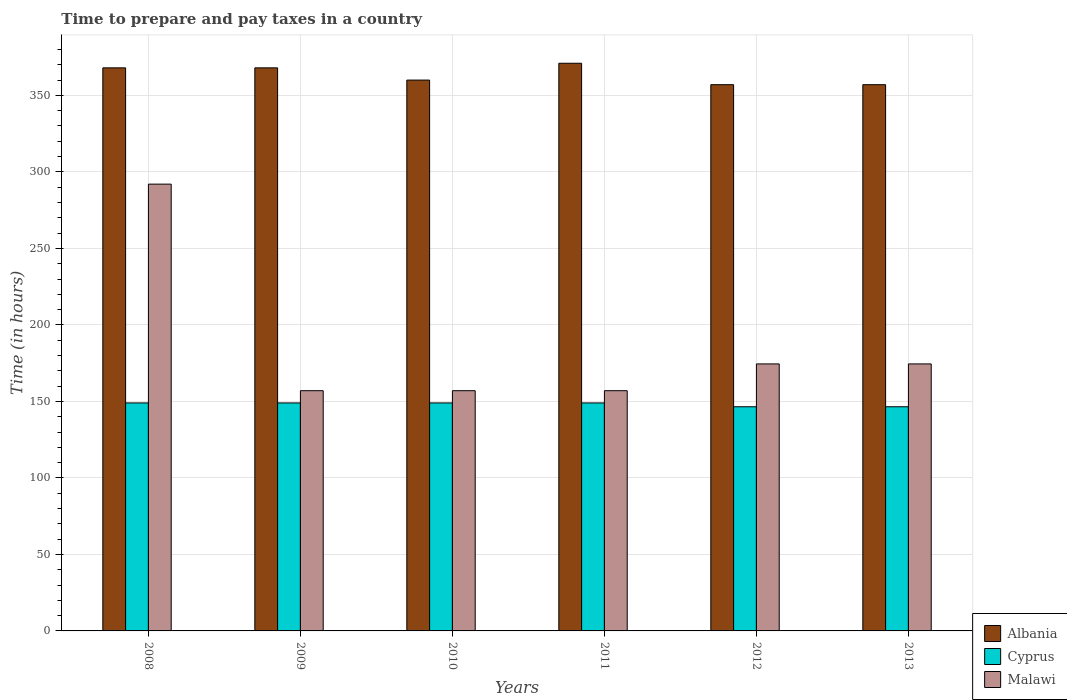How many different coloured bars are there?
Provide a succinct answer. 3. How many groups of bars are there?
Make the answer very short. 6. Are the number of bars per tick equal to the number of legend labels?
Offer a very short reply. Yes. How many bars are there on the 4th tick from the left?
Ensure brevity in your answer.  3. How many bars are there on the 4th tick from the right?
Offer a terse response. 3. In how many cases, is the number of bars for a given year not equal to the number of legend labels?
Your answer should be very brief. 0. What is the number of hours required to prepare and pay taxes in Cyprus in 2012?
Your answer should be compact. 146.5. Across all years, what is the maximum number of hours required to prepare and pay taxes in Malawi?
Your answer should be very brief. 292. Across all years, what is the minimum number of hours required to prepare and pay taxes in Cyprus?
Ensure brevity in your answer.  146.5. In which year was the number of hours required to prepare and pay taxes in Malawi maximum?
Provide a succinct answer. 2008. What is the total number of hours required to prepare and pay taxes in Malawi in the graph?
Provide a succinct answer. 1112. What is the difference between the number of hours required to prepare and pay taxes in Malawi in 2010 and that in 2012?
Provide a succinct answer. -17.5. What is the difference between the number of hours required to prepare and pay taxes in Malawi in 2011 and the number of hours required to prepare and pay taxes in Albania in 2012?
Make the answer very short. -200. What is the average number of hours required to prepare and pay taxes in Cyprus per year?
Your answer should be compact. 148.17. In the year 2009, what is the difference between the number of hours required to prepare and pay taxes in Cyprus and number of hours required to prepare and pay taxes in Albania?
Ensure brevity in your answer.  -219. What is the ratio of the number of hours required to prepare and pay taxes in Albania in 2011 to that in 2013?
Offer a very short reply. 1.04. Is the number of hours required to prepare and pay taxes in Malawi in 2008 less than that in 2009?
Offer a terse response. No. Is the difference between the number of hours required to prepare and pay taxes in Cyprus in 2009 and 2013 greater than the difference between the number of hours required to prepare and pay taxes in Albania in 2009 and 2013?
Offer a terse response. No. What is the difference between the highest and the lowest number of hours required to prepare and pay taxes in Cyprus?
Your answer should be very brief. 2.5. In how many years, is the number of hours required to prepare and pay taxes in Cyprus greater than the average number of hours required to prepare and pay taxes in Cyprus taken over all years?
Make the answer very short. 4. Is the sum of the number of hours required to prepare and pay taxes in Cyprus in 2008 and 2009 greater than the maximum number of hours required to prepare and pay taxes in Albania across all years?
Give a very brief answer. No. What does the 1st bar from the left in 2009 represents?
Make the answer very short. Albania. What does the 3rd bar from the right in 2012 represents?
Give a very brief answer. Albania. Is it the case that in every year, the sum of the number of hours required to prepare and pay taxes in Cyprus and number of hours required to prepare and pay taxes in Malawi is greater than the number of hours required to prepare and pay taxes in Albania?
Your response must be concise. No. Does the graph contain any zero values?
Provide a short and direct response. No. How are the legend labels stacked?
Keep it short and to the point. Vertical. What is the title of the graph?
Your answer should be very brief. Time to prepare and pay taxes in a country. Does "Austria" appear as one of the legend labels in the graph?
Provide a succinct answer. No. What is the label or title of the X-axis?
Offer a very short reply. Years. What is the label or title of the Y-axis?
Ensure brevity in your answer.  Time (in hours). What is the Time (in hours) in Albania in 2008?
Ensure brevity in your answer.  368. What is the Time (in hours) in Cyprus in 2008?
Give a very brief answer. 149. What is the Time (in hours) in Malawi in 2008?
Give a very brief answer. 292. What is the Time (in hours) of Albania in 2009?
Offer a very short reply. 368. What is the Time (in hours) in Cyprus in 2009?
Give a very brief answer. 149. What is the Time (in hours) in Malawi in 2009?
Your answer should be very brief. 157. What is the Time (in hours) of Albania in 2010?
Offer a terse response. 360. What is the Time (in hours) in Cyprus in 2010?
Ensure brevity in your answer.  149. What is the Time (in hours) of Malawi in 2010?
Keep it short and to the point. 157. What is the Time (in hours) of Albania in 2011?
Offer a very short reply. 371. What is the Time (in hours) in Cyprus in 2011?
Your response must be concise. 149. What is the Time (in hours) in Malawi in 2011?
Provide a succinct answer. 157. What is the Time (in hours) of Albania in 2012?
Ensure brevity in your answer.  357. What is the Time (in hours) in Cyprus in 2012?
Keep it short and to the point. 146.5. What is the Time (in hours) in Malawi in 2012?
Offer a very short reply. 174.5. What is the Time (in hours) in Albania in 2013?
Give a very brief answer. 357. What is the Time (in hours) of Cyprus in 2013?
Offer a terse response. 146.5. What is the Time (in hours) in Malawi in 2013?
Provide a short and direct response. 174.5. Across all years, what is the maximum Time (in hours) of Albania?
Your answer should be compact. 371. Across all years, what is the maximum Time (in hours) of Cyprus?
Keep it short and to the point. 149. Across all years, what is the maximum Time (in hours) of Malawi?
Make the answer very short. 292. Across all years, what is the minimum Time (in hours) of Albania?
Offer a terse response. 357. Across all years, what is the minimum Time (in hours) in Cyprus?
Your response must be concise. 146.5. Across all years, what is the minimum Time (in hours) in Malawi?
Ensure brevity in your answer.  157. What is the total Time (in hours) in Albania in the graph?
Give a very brief answer. 2181. What is the total Time (in hours) of Cyprus in the graph?
Your answer should be compact. 889. What is the total Time (in hours) in Malawi in the graph?
Ensure brevity in your answer.  1112. What is the difference between the Time (in hours) of Albania in 2008 and that in 2009?
Provide a short and direct response. 0. What is the difference between the Time (in hours) in Malawi in 2008 and that in 2009?
Your answer should be very brief. 135. What is the difference between the Time (in hours) of Albania in 2008 and that in 2010?
Your answer should be very brief. 8. What is the difference between the Time (in hours) in Malawi in 2008 and that in 2010?
Give a very brief answer. 135. What is the difference between the Time (in hours) of Albania in 2008 and that in 2011?
Ensure brevity in your answer.  -3. What is the difference between the Time (in hours) of Malawi in 2008 and that in 2011?
Give a very brief answer. 135. What is the difference between the Time (in hours) of Albania in 2008 and that in 2012?
Provide a succinct answer. 11. What is the difference between the Time (in hours) in Cyprus in 2008 and that in 2012?
Keep it short and to the point. 2.5. What is the difference between the Time (in hours) of Malawi in 2008 and that in 2012?
Your answer should be compact. 117.5. What is the difference between the Time (in hours) in Albania in 2008 and that in 2013?
Provide a succinct answer. 11. What is the difference between the Time (in hours) of Cyprus in 2008 and that in 2013?
Your answer should be compact. 2.5. What is the difference between the Time (in hours) of Malawi in 2008 and that in 2013?
Provide a short and direct response. 117.5. What is the difference between the Time (in hours) of Cyprus in 2009 and that in 2010?
Offer a terse response. 0. What is the difference between the Time (in hours) in Malawi in 2009 and that in 2010?
Ensure brevity in your answer.  0. What is the difference between the Time (in hours) of Cyprus in 2009 and that in 2011?
Provide a succinct answer. 0. What is the difference between the Time (in hours) of Malawi in 2009 and that in 2011?
Make the answer very short. 0. What is the difference between the Time (in hours) in Albania in 2009 and that in 2012?
Offer a very short reply. 11. What is the difference between the Time (in hours) in Malawi in 2009 and that in 2012?
Keep it short and to the point. -17.5. What is the difference between the Time (in hours) in Cyprus in 2009 and that in 2013?
Provide a short and direct response. 2.5. What is the difference between the Time (in hours) of Malawi in 2009 and that in 2013?
Make the answer very short. -17.5. What is the difference between the Time (in hours) in Albania in 2010 and that in 2011?
Your answer should be very brief. -11. What is the difference between the Time (in hours) in Cyprus in 2010 and that in 2011?
Ensure brevity in your answer.  0. What is the difference between the Time (in hours) of Malawi in 2010 and that in 2011?
Provide a short and direct response. 0. What is the difference between the Time (in hours) of Albania in 2010 and that in 2012?
Make the answer very short. 3. What is the difference between the Time (in hours) in Cyprus in 2010 and that in 2012?
Keep it short and to the point. 2.5. What is the difference between the Time (in hours) in Malawi in 2010 and that in 2012?
Keep it short and to the point. -17.5. What is the difference between the Time (in hours) of Cyprus in 2010 and that in 2013?
Offer a terse response. 2.5. What is the difference between the Time (in hours) of Malawi in 2010 and that in 2013?
Ensure brevity in your answer.  -17.5. What is the difference between the Time (in hours) of Cyprus in 2011 and that in 2012?
Keep it short and to the point. 2.5. What is the difference between the Time (in hours) of Malawi in 2011 and that in 2012?
Offer a very short reply. -17.5. What is the difference between the Time (in hours) in Cyprus in 2011 and that in 2013?
Keep it short and to the point. 2.5. What is the difference between the Time (in hours) in Malawi in 2011 and that in 2013?
Keep it short and to the point. -17.5. What is the difference between the Time (in hours) in Albania in 2012 and that in 2013?
Ensure brevity in your answer.  0. What is the difference between the Time (in hours) of Cyprus in 2012 and that in 2013?
Give a very brief answer. 0. What is the difference between the Time (in hours) of Malawi in 2012 and that in 2013?
Offer a very short reply. 0. What is the difference between the Time (in hours) of Albania in 2008 and the Time (in hours) of Cyprus in 2009?
Provide a short and direct response. 219. What is the difference between the Time (in hours) in Albania in 2008 and the Time (in hours) in Malawi in 2009?
Provide a succinct answer. 211. What is the difference between the Time (in hours) in Cyprus in 2008 and the Time (in hours) in Malawi in 2009?
Your answer should be compact. -8. What is the difference between the Time (in hours) of Albania in 2008 and the Time (in hours) of Cyprus in 2010?
Provide a short and direct response. 219. What is the difference between the Time (in hours) of Albania in 2008 and the Time (in hours) of Malawi in 2010?
Your response must be concise. 211. What is the difference between the Time (in hours) of Cyprus in 2008 and the Time (in hours) of Malawi in 2010?
Offer a terse response. -8. What is the difference between the Time (in hours) in Albania in 2008 and the Time (in hours) in Cyprus in 2011?
Make the answer very short. 219. What is the difference between the Time (in hours) in Albania in 2008 and the Time (in hours) in Malawi in 2011?
Keep it short and to the point. 211. What is the difference between the Time (in hours) of Albania in 2008 and the Time (in hours) of Cyprus in 2012?
Your answer should be very brief. 221.5. What is the difference between the Time (in hours) of Albania in 2008 and the Time (in hours) of Malawi in 2012?
Offer a very short reply. 193.5. What is the difference between the Time (in hours) of Cyprus in 2008 and the Time (in hours) of Malawi in 2012?
Your answer should be compact. -25.5. What is the difference between the Time (in hours) of Albania in 2008 and the Time (in hours) of Cyprus in 2013?
Make the answer very short. 221.5. What is the difference between the Time (in hours) of Albania in 2008 and the Time (in hours) of Malawi in 2013?
Ensure brevity in your answer.  193.5. What is the difference between the Time (in hours) in Cyprus in 2008 and the Time (in hours) in Malawi in 2013?
Your response must be concise. -25.5. What is the difference between the Time (in hours) in Albania in 2009 and the Time (in hours) in Cyprus in 2010?
Make the answer very short. 219. What is the difference between the Time (in hours) of Albania in 2009 and the Time (in hours) of Malawi in 2010?
Provide a short and direct response. 211. What is the difference between the Time (in hours) in Cyprus in 2009 and the Time (in hours) in Malawi in 2010?
Your answer should be compact. -8. What is the difference between the Time (in hours) in Albania in 2009 and the Time (in hours) in Cyprus in 2011?
Offer a terse response. 219. What is the difference between the Time (in hours) in Albania in 2009 and the Time (in hours) in Malawi in 2011?
Offer a very short reply. 211. What is the difference between the Time (in hours) in Albania in 2009 and the Time (in hours) in Cyprus in 2012?
Provide a succinct answer. 221.5. What is the difference between the Time (in hours) of Albania in 2009 and the Time (in hours) of Malawi in 2012?
Keep it short and to the point. 193.5. What is the difference between the Time (in hours) in Cyprus in 2009 and the Time (in hours) in Malawi in 2012?
Provide a short and direct response. -25.5. What is the difference between the Time (in hours) in Albania in 2009 and the Time (in hours) in Cyprus in 2013?
Provide a succinct answer. 221.5. What is the difference between the Time (in hours) of Albania in 2009 and the Time (in hours) of Malawi in 2013?
Ensure brevity in your answer.  193.5. What is the difference between the Time (in hours) of Cyprus in 2009 and the Time (in hours) of Malawi in 2013?
Provide a succinct answer. -25.5. What is the difference between the Time (in hours) of Albania in 2010 and the Time (in hours) of Cyprus in 2011?
Offer a terse response. 211. What is the difference between the Time (in hours) of Albania in 2010 and the Time (in hours) of Malawi in 2011?
Keep it short and to the point. 203. What is the difference between the Time (in hours) of Albania in 2010 and the Time (in hours) of Cyprus in 2012?
Your answer should be very brief. 213.5. What is the difference between the Time (in hours) of Albania in 2010 and the Time (in hours) of Malawi in 2012?
Keep it short and to the point. 185.5. What is the difference between the Time (in hours) in Cyprus in 2010 and the Time (in hours) in Malawi in 2012?
Keep it short and to the point. -25.5. What is the difference between the Time (in hours) of Albania in 2010 and the Time (in hours) of Cyprus in 2013?
Provide a short and direct response. 213.5. What is the difference between the Time (in hours) in Albania in 2010 and the Time (in hours) in Malawi in 2013?
Provide a short and direct response. 185.5. What is the difference between the Time (in hours) of Cyprus in 2010 and the Time (in hours) of Malawi in 2013?
Your response must be concise. -25.5. What is the difference between the Time (in hours) in Albania in 2011 and the Time (in hours) in Cyprus in 2012?
Offer a very short reply. 224.5. What is the difference between the Time (in hours) of Albania in 2011 and the Time (in hours) of Malawi in 2012?
Your answer should be compact. 196.5. What is the difference between the Time (in hours) of Cyprus in 2011 and the Time (in hours) of Malawi in 2012?
Ensure brevity in your answer.  -25.5. What is the difference between the Time (in hours) of Albania in 2011 and the Time (in hours) of Cyprus in 2013?
Provide a succinct answer. 224.5. What is the difference between the Time (in hours) in Albania in 2011 and the Time (in hours) in Malawi in 2013?
Your response must be concise. 196.5. What is the difference between the Time (in hours) in Cyprus in 2011 and the Time (in hours) in Malawi in 2013?
Offer a very short reply. -25.5. What is the difference between the Time (in hours) of Albania in 2012 and the Time (in hours) of Cyprus in 2013?
Make the answer very short. 210.5. What is the difference between the Time (in hours) of Albania in 2012 and the Time (in hours) of Malawi in 2013?
Keep it short and to the point. 182.5. What is the average Time (in hours) in Albania per year?
Provide a succinct answer. 363.5. What is the average Time (in hours) in Cyprus per year?
Ensure brevity in your answer.  148.17. What is the average Time (in hours) in Malawi per year?
Your answer should be very brief. 185.33. In the year 2008, what is the difference between the Time (in hours) in Albania and Time (in hours) in Cyprus?
Make the answer very short. 219. In the year 2008, what is the difference between the Time (in hours) of Cyprus and Time (in hours) of Malawi?
Keep it short and to the point. -143. In the year 2009, what is the difference between the Time (in hours) in Albania and Time (in hours) in Cyprus?
Ensure brevity in your answer.  219. In the year 2009, what is the difference between the Time (in hours) of Albania and Time (in hours) of Malawi?
Provide a succinct answer. 211. In the year 2009, what is the difference between the Time (in hours) in Cyprus and Time (in hours) in Malawi?
Provide a short and direct response. -8. In the year 2010, what is the difference between the Time (in hours) of Albania and Time (in hours) of Cyprus?
Your response must be concise. 211. In the year 2010, what is the difference between the Time (in hours) of Albania and Time (in hours) of Malawi?
Provide a succinct answer. 203. In the year 2011, what is the difference between the Time (in hours) of Albania and Time (in hours) of Cyprus?
Your answer should be very brief. 222. In the year 2011, what is the difference between the Time (in hours) of Albania and Time (in hours) of Malawi?
Make the answer very short. 214. In the year 2012, what is the difference between the Time (in hours) in Albania and Time (in hours) in Cyprus?
Offer a terse response. 210.5. In the year 2012, what is the difference between the Time (in hours) of Albania and Time (in hours) of Malawi?
Your answer should be compact. 182.5. In the year 2013, what is the difference between the Time (in hours) in Albania and Time (in hours) in Cyprus?
Your answer should be very brief. 210.5. In the year 2013, what is the difference between the Time (in hours) of Albania and Time (in hours) of Malawi?
Your answer should be very brief. 182.5. What is the ratio of the Time (in hours) of Malawi in 2008 to that in 2009?
Your answer should be compact. 1.86. What is the ratio of the Time (in hours) in Albania in 2008 to that in 2010?
Offer a terse response. 1.02. What is the ratio of the Time (in hours) of Malawi in 2008 to that in 2010?
Provide a succinct answer. 1.86. What is the ratio of the Time (in hours) in Cyprus in 2008 to that in 2011?
Your answer should be compact. 1. What is the ratio of the Time (in hours) in Malawi in 2008 to that in 2011?
Your answer should be compact. 1.86. What is the ratio of the Time (in hours) in Albania in 2008 to that in 2012?
Make the answer very short. 1.03. What is the ratio of the Time (in hours) in Cyprus in 2008 to that in 2012?
Ensure brevity in your answer.  1.02. What is the ratio of the Time (in hours) in Malawi in 2008 to that in 2012?
Provide a succinct answer. 1.67. What is the ratio of the Time (in hours) of Albania in 2008 to that in 2013?
Provide a succinct answer. 1.03. What is the ratio of the Time (in hours) of Cyprus in 2008 to that in 2013?
Offer a very short reply. 1.02. What is the ratio of the Time (in hours) in Malawi in 2008 to that in 2013?
Your answer should be very brief. 1.67. What is the ratio of the Time (in hours) of Albania in 2009 to that in 2010?
Make the answer very short. 1.02. What is the ratio of the Time (in hours) in Cyprus in 2009 to that in 2010?
Offer a very short reply. 1. What is the ratio of the Time (in hours) of Malawi in 2009 to that in 2011?
Offer a very short reply. 1. What is the ratio of the Time (in hours) of Albania in 2009 to that in 2012?
Give a very brief answer. 1.03. What is the ratio of the Time (in hours) in Cyprus in 2009 to that in 2012?
Your answer should be very brief. 1.02. What is the ratio of the Time (in hours) of Malawi in 2009 to that in 2012?
Your answer should be very brief. 0.9. What is the ratio of the Time (in hours) of Albania in 2009 to that in 2013?
Provide a short and direct response. 1.03. What is the ratio of the Time (in hours) in Cyprus in 2009 to that in 2013?
Provide a succinct answer. 1.02. What is the ratio of the Time (in hours) in Malawi in 2009 to that in 2013?
Offer a terse response. 0.9. What is the ratio of the Time (in hours) in Albania in 2010 to that in 2011?
Ensure brevity in your answer.  0.97. What is the ratio of the Time (in hours) of Albania in 2010 to that in 2012?
Your response must be concise. 1.01. What is the ratio of the Time (in hours) of Cyprus in 2010 to that in 2012?
Provide a succinct answer. 1.02. What is the ratio of the Time (in hours) in Malawi in 2010 to that in 2012?
Your response must be concise. 0.9. What is the ratio of the Time (in hours) in Albania in 2010 to that in 2013?
Keep it short and to the point. 1.01. What is the ratio of the Time (in hours) of Cyprus in 2010 to that in 2013?
Make the answer very short. 1.02. What is the ratio of the Time (in hours) of Malawi in 2010 to that in 2013?
Ensure brevity in your answer.  0.9. What is the ratio of the Time (in hours) of Albania in 2011 to that in 2012?
Your response must be concise. 1.04. What is the ratio of the Time (in hours) in Cyprus in 2011 to that in 2012?
Keep it short and to the point. 1.02. What is the ratio of the Time (in hours) in Malawi in 2011 to that in 2012?
Provide a succinct answer. 0.9. What is the ratio of the Time (in hours) of Albania in 2011 to that in 2013?
Your answer should be compact. 1.04. What is the ratio of the Time (in hours) in Cyprus in 2011 to that in 2013?
Make the answer very short. 1.02. What is the ratio of the Time (in hours) of Malawi in 2011 to that in 2013?
Your response must be concise. 0.9. What is the difference between the highest and the second highest Time (in hours) in Cyprus?
Offer a very short reply. 0. What is the difference between the highest and the second highest Time (in hours) of Malawi?
Ensure brevity in your answer.  117.5. What is the difference between the highest and the lowest Time (in hours) of Albania?
Offer a very short reply. 14. What is the difference between the highest and the lowest Time (in hours) of Cyprus?
Your answer should be very brief. 2.5. What is the difference between the highest and the lowest Time (in hours) of Malawi?
Offer a terse response. 135. 